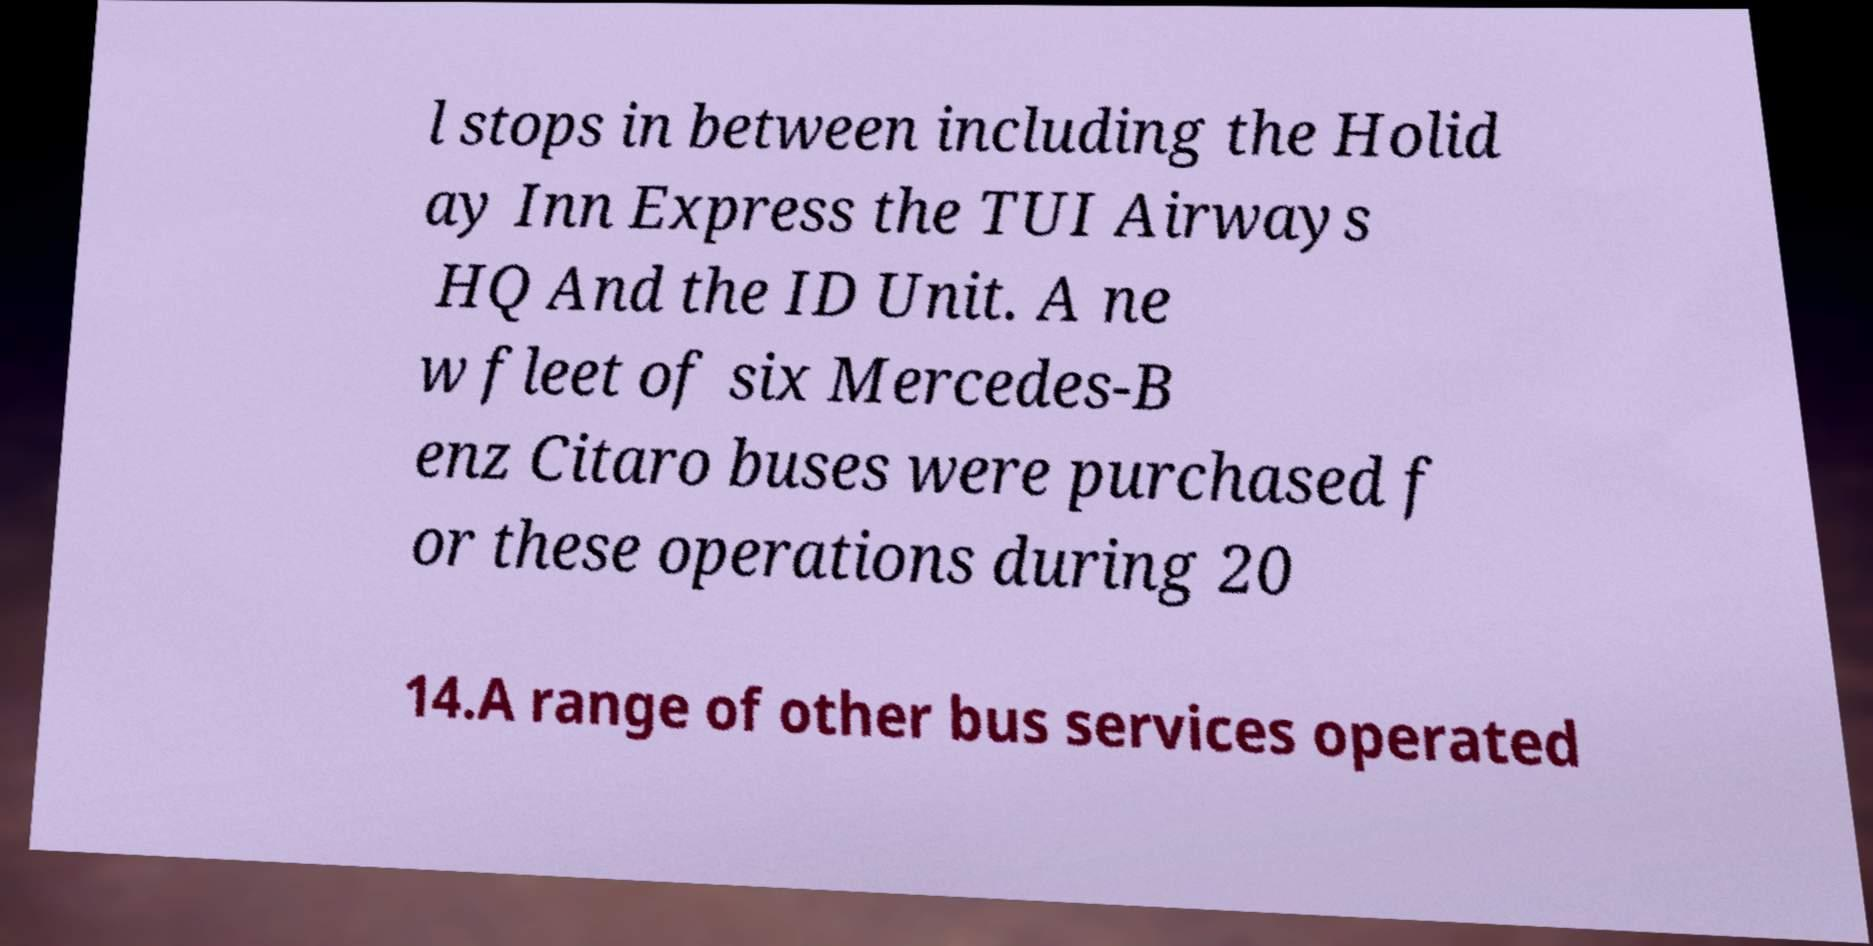Can you accurately transcribe the text from the provided image for me? l stops in between including the Holid ay Inn Express the TUI Airways HQ And the ID Unit. A ne w fleet of six Mercedes-B enz Citaro buses were purchased f or these operations during 20 14.A range of other bus services operated 